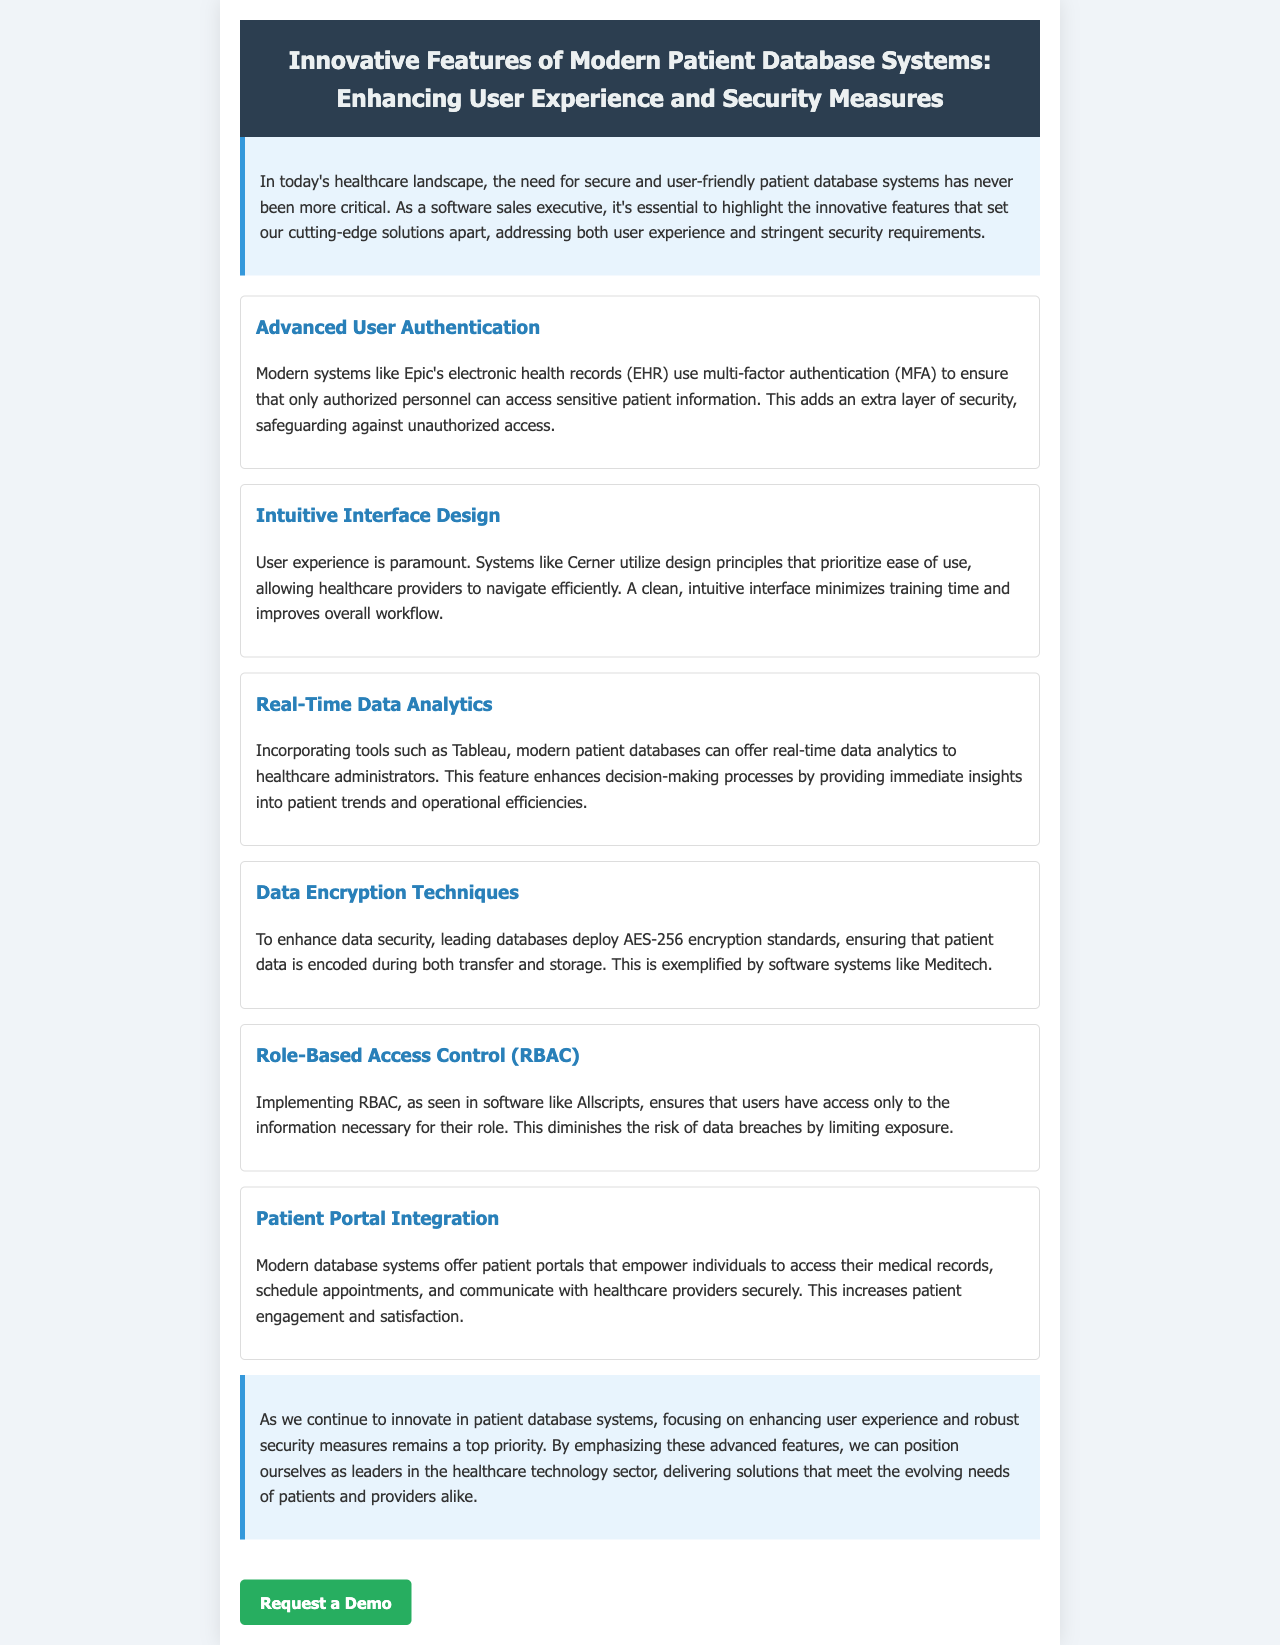What system uses multi-factor authentication? The document states that Epic's electronic health records (EHR) use multi-factor authentication (MFA) for security.
Answer: Epic's electronic health records (EHR) What feature allows users to only access necessary information? Role-Based Access Control (RBAC) is mentioned as a feature that limits users' access to necessary information.
Answer: Role-Based Access Control (RBAC) Which encryption standard is used for data security? The document specifies that leading databases deploy AES-256 encryption standards to secure patient data.
Answer: AES-256 What design principle is prioritized for user experience in systems like Cerner? It is stated that an intuitive interface design prioritizes ease of use for healthcare providers.
Answer: Intuitive interface design What does modern patient database systems integrate to enhance patient engagement? The document highlights patient portal integration as a feature that empowers individuals with access to their medical records and communication with providers.
Answer: Patient portal integration Which tool provides real-time data analytics in modern patient databases? The document mentions that tools like Tableau offer real-time data analytics to healthcare administrators.
Answer: Tableau What is the focus of modern patient database systems according to the conclusion? The conclusion emphasizes the ongoing innovation in enhancing user experience and robust security measures in patient database systems.
Answer: Enhancing user experience and robust security measures 